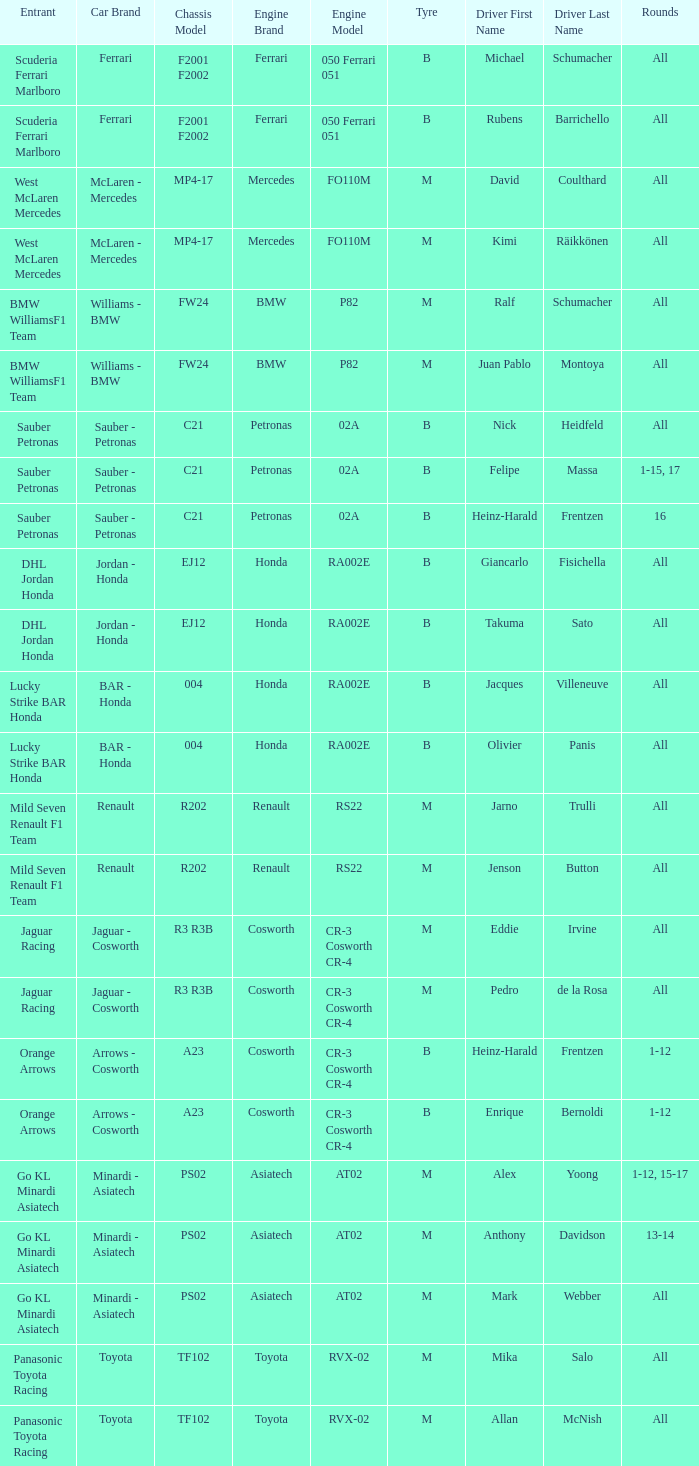What is the rounds when the engine is mercedes fo110m? All, All. 